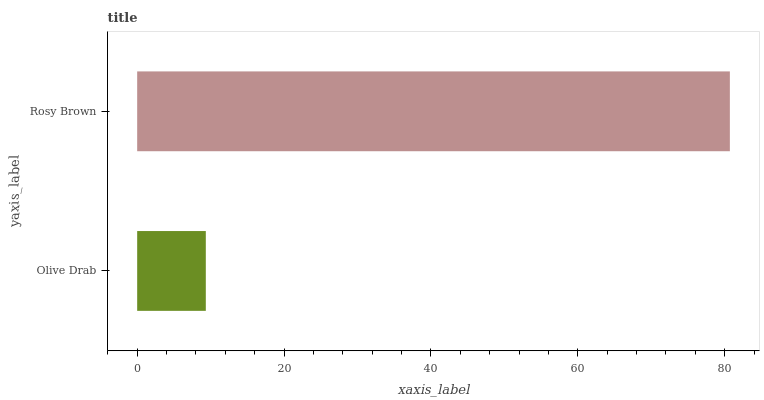Is Olive Drab the minimum?
Answer yes or no. Yes. Is Rosy Brown the maximum?
Answer yes or no. Yes. Is Rosy Brown the minimum?
Answer yes or no. No. Is Rosy Brown greater than Olive Drab?
Answer yes or no. Yes. Is Olive Drab less than Rosy Brown?
Answer yes or no. Yes. Is Olive Drab greater than Rosy Brown?
Answer yes or no. No. Is Rosy Brown less than Olive Drab?
Answer yes or no. No. Is Rosy Brown the high median?
Answer yes or no. Yes. Is Olive Drab the low median?
Answer yes or no. Yes. Is Olive Drab the high median?
Answer yes or no. No. Is Rosy Brown the low median?
Answer yes or no. No. 